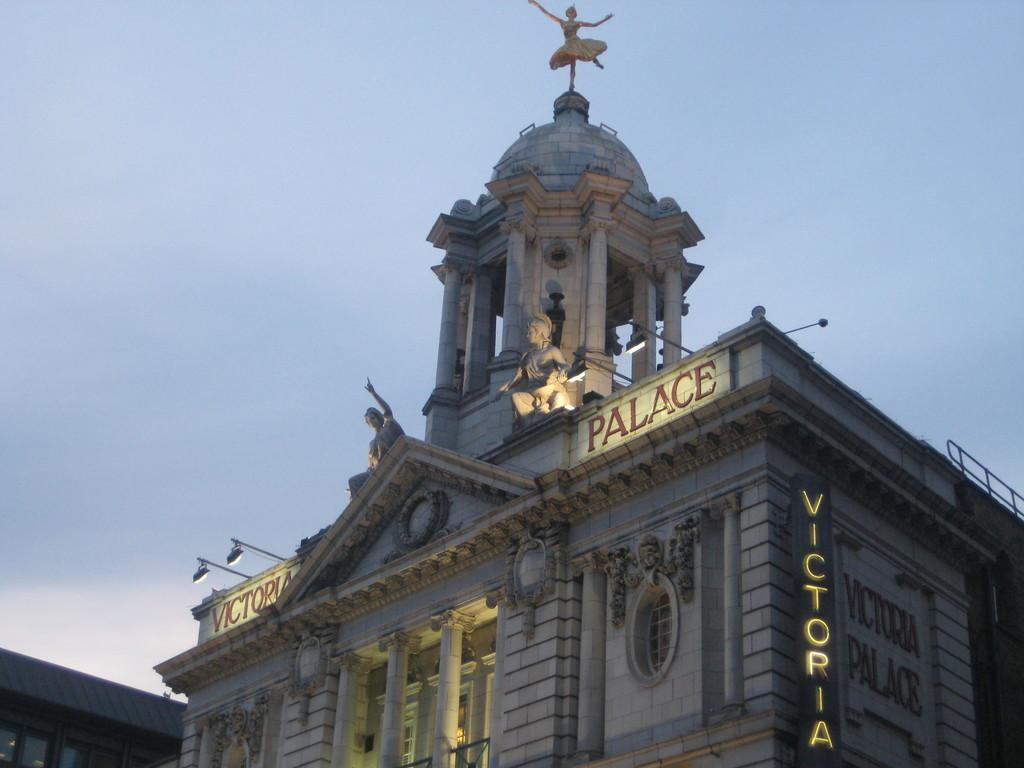What type of structure is in the picture? There is a building in the picture. What features can be seen on the building? The building has windows and pillars. What other objects are present in the picture? There are poles and lights in the picture. Is there any text visible in the image? Yes, there is text visible in the picture. What can be seen in the background of the picture? The sky is visible in the picture. What type of end is attached to the tail of the beginner in the image? There is no person or tail present in the image; it features a building with windows, pillars, poles, lights, text, and a visible sky. 